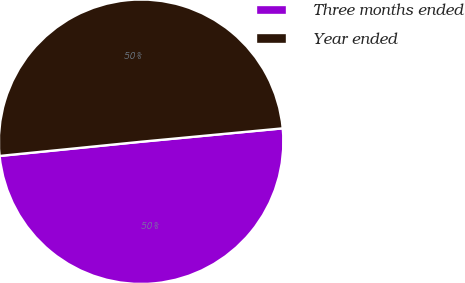Convert chart to OTSL. <chart><loc_0><loc_0><loc_500><loc_500><pie_chart><fcel>Three months ended<fcel>Year ended<nl><fcel>49.91%<fcel>50.09%<nl></chart> 